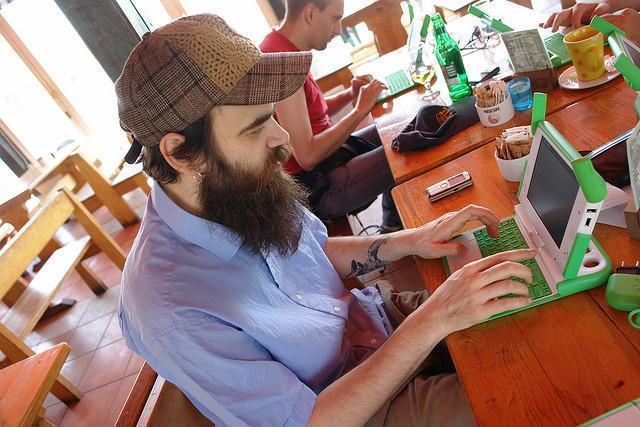How many chairs can be seen?
Give a very brief answer. 2. How many people can be seen?
Give a very brief answer. 3. How many dining tables are in the photo?
Give a very brief answer. 3. 